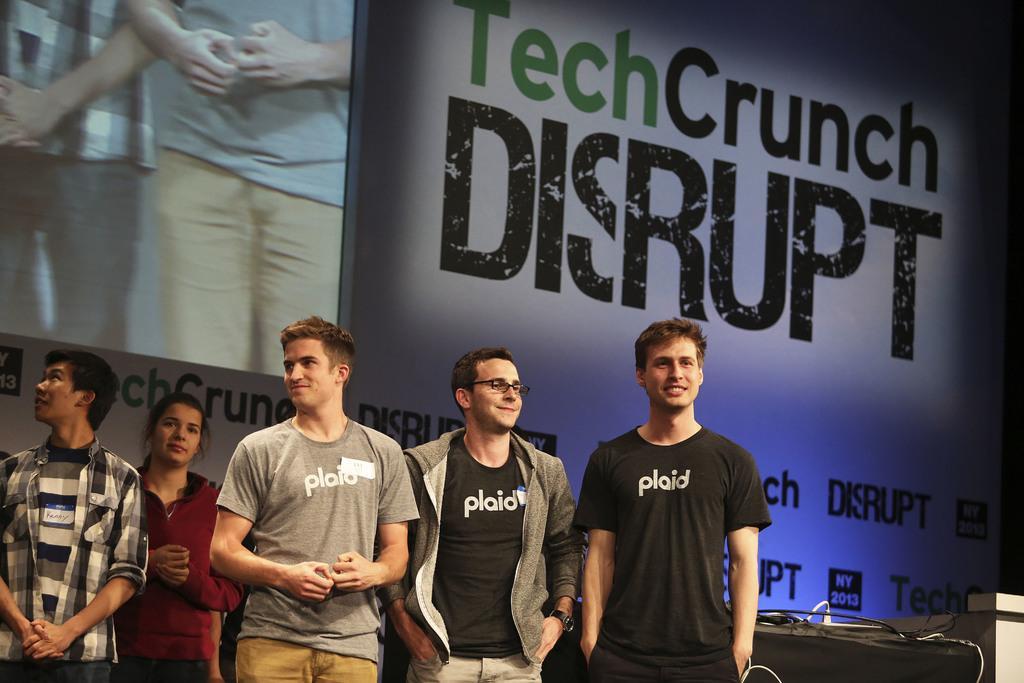How would you summarize this image in a sentence or two? In this image we can see people standing. In the background of the image there is screen. There is some text. There is a table on which there are objects. 